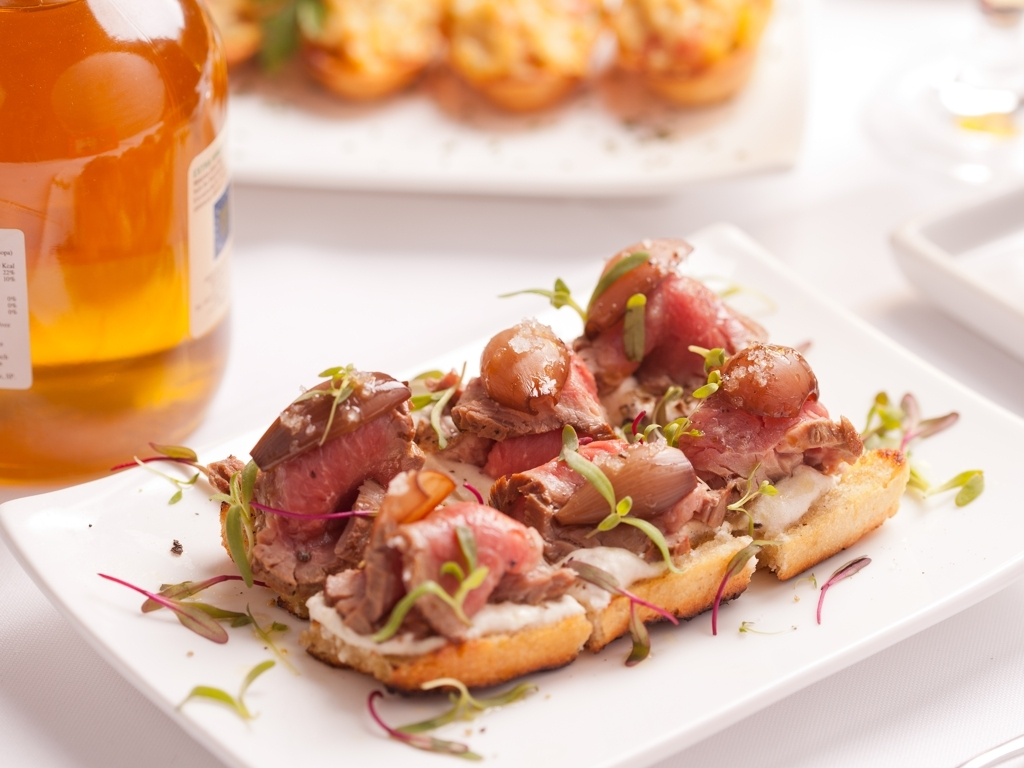Is the quality of this image high? The image is of above-average quality with good lighting and focus, capturing the textures and colors of the dish in a way that conveys the appetizing nature of the meal. However, there are elements that could be improved for an even higher quality, such as a more varied angle or perspective to add depth, and perhaps a cleaner background to minimize distractions. 